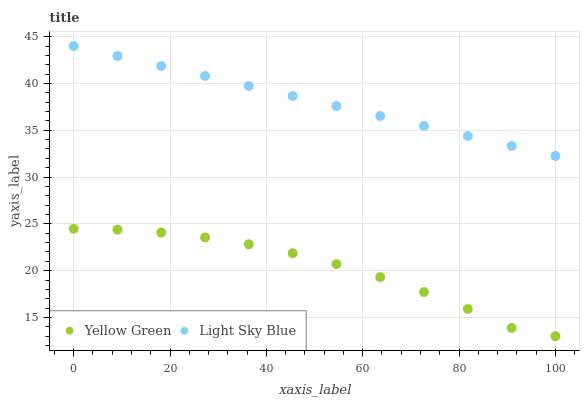Does Yellow Green have the minimum area under the curve?
Answer yes or no. Yes. Does Light Sky Blue have the maximum area under the curve?
Answer yes or no. Yes. Does Yellow Green have the maximum area under the curve?
Answer yes or no. No. Is Light Sky Blue the smoothest?
Answer yes or no. Yes. Is Yellow Green the roughest?
Answer yes or no. Yes. Is Yellow Green the smoothest?
Answer yes or no. No. Does Yellow Green have the lowest value?
Answer yes or no. Yes. Does Light Sky Blue have the highest value?
Answer yes or no. Yes. Does Yellow Green have the highest value?
Answer yes or no. No. Is Yellow Green less than Light Sky Blue?
Answer yes or no. Yes. Is Light Sky Blue greater than Yellow Green?
Answer yes or no. Yes. Does Yellow Green intersect Light Sky Blue?
Answer yes or no. No. 